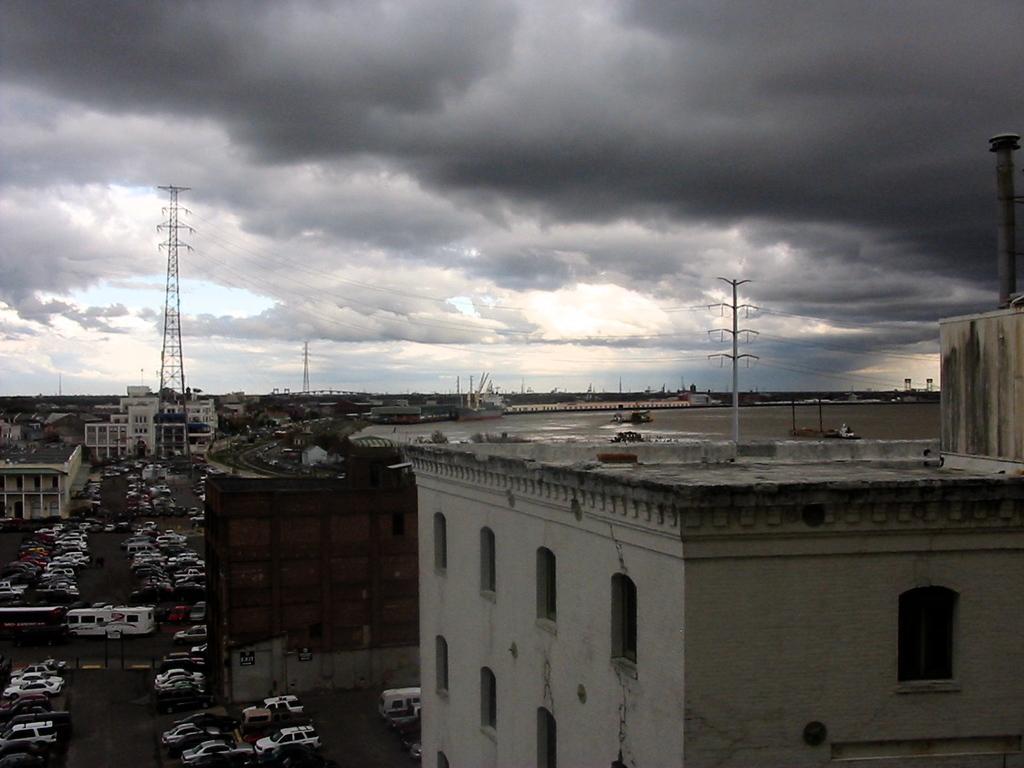Can you describe this image briefly? In this image there are buildings, towers and some vehicles, and at the bottom there is road and also there is a hoarding. And in the background there are towers and wires, at the top there is sky and the sky is cloudy. 